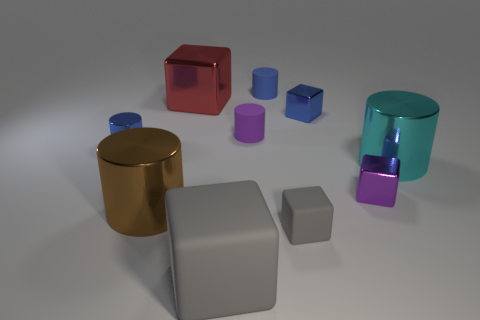Subtract all matte cubes. How many cubes are left? 3 Subtract all green cylinders. How many gray blocks are left? 2 Subtract all blue cylinders. How many cylinders are left? 3 Subtract 3 cylinders. How many cylinders are left? 2 Add 1 large matte objects. How many large matte objects are left? 2 Add 7 cyan shiny cylinders. How many cyan shiny cylinders exist? 8 Subtract 0 gray spheres. How many objects are left? 10 Subtract all gray cylinders. Subtract all blue blocks. How many cylinders are left? 5 Subtract all small blue shiny things. Subtract all tiny blue blocks. How many objects are left? 7 